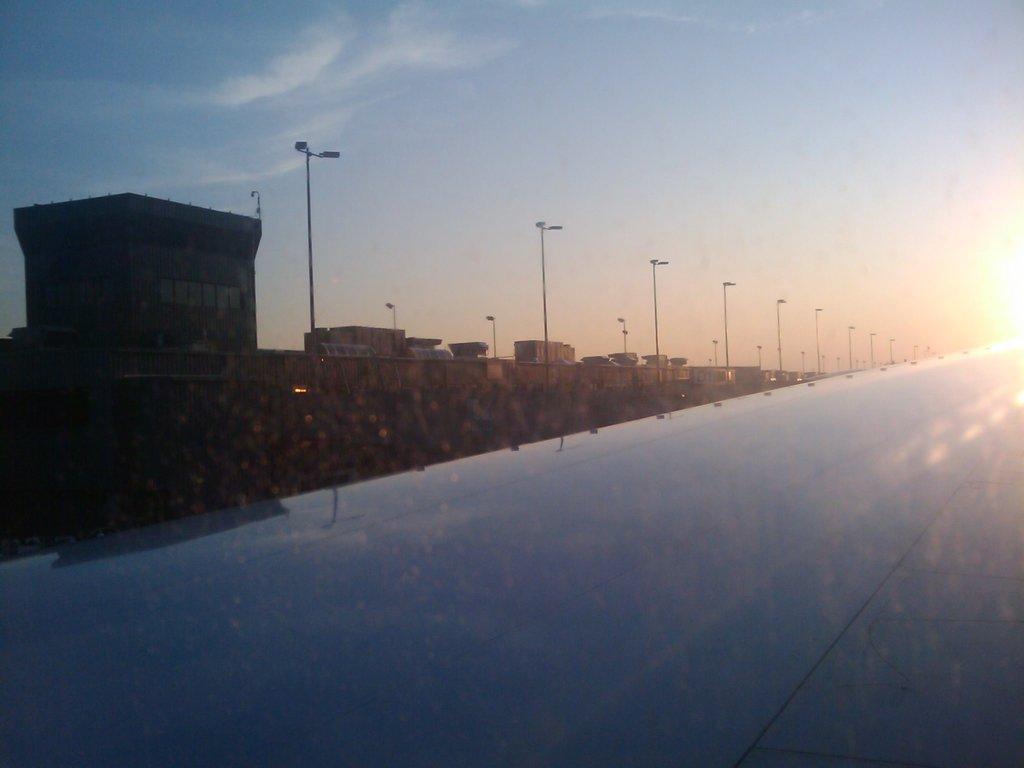In one or two sentences, can you explain what this image depicts? In this picture I can see there is a road and there are few poles with lights and there are a few buildings at left side and the sky is clear and sunny. 